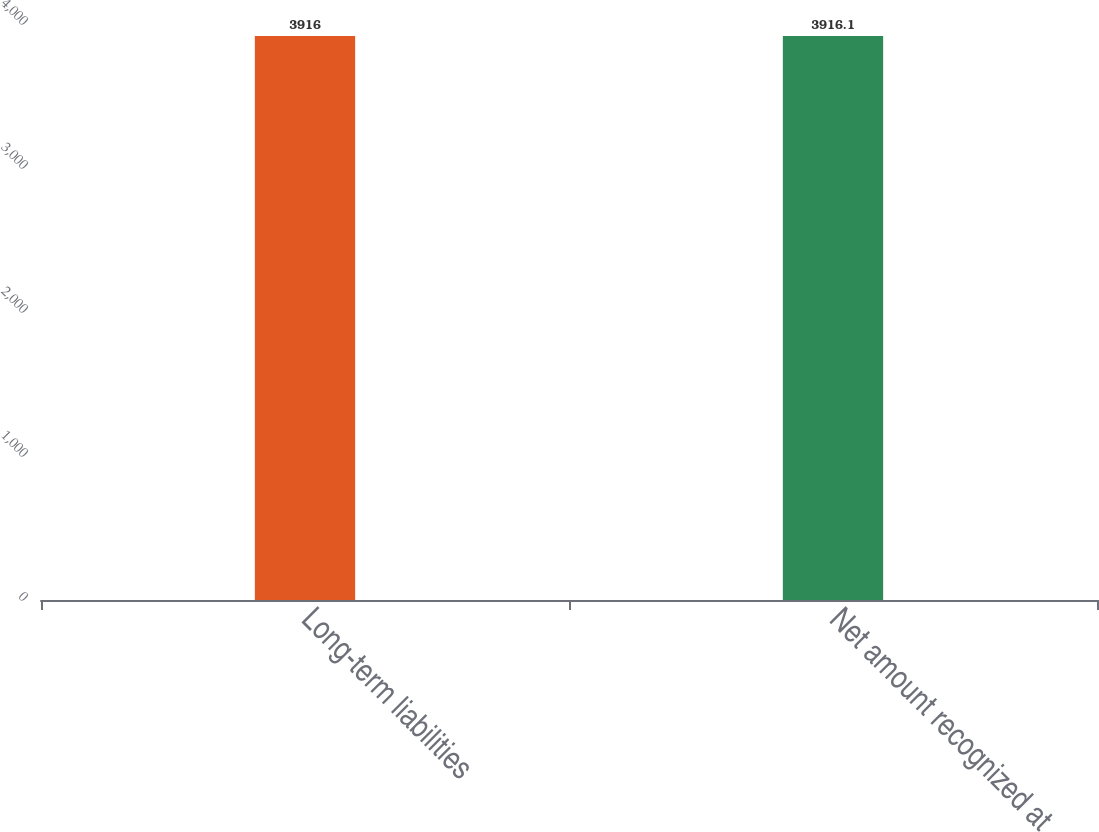Convert chart to OTSL. <chart><loc_0><loc_0><loc_500><loc_500><bar_chart><fcel>Long-term liabilities<fcel>Net amount recognized at<nl><fcel>3916<fcel>3916.1<nl></chart> 